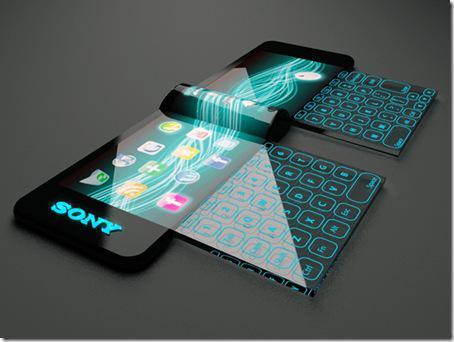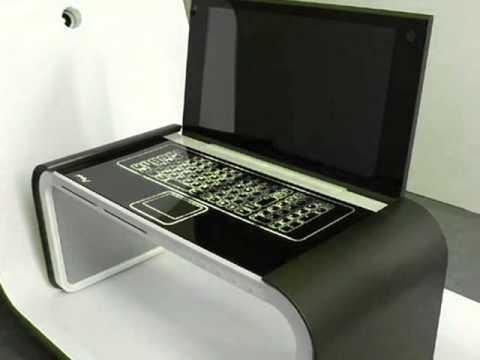The first image is the image on the left, the second image is the image on the right. Analyze the images presented: Is the assertion "The laptop on the right has a slightly curved, concave screen." valid? Answer yes or no. No. 